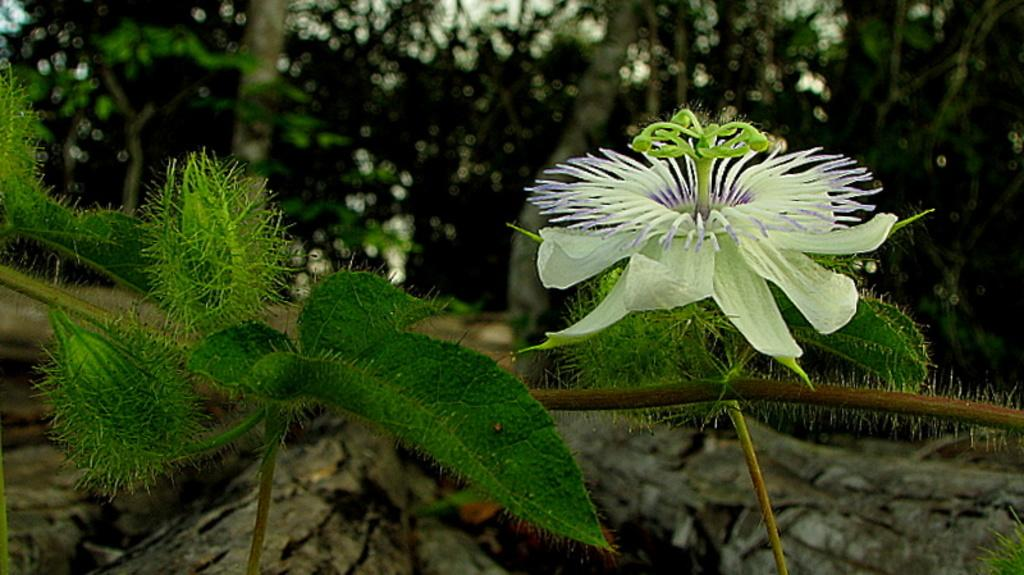What type of flora can be seen in the image? There are flowers and plants in the image. What other elements related to flora are present in the image? There are trunks and trees in the image. How would you describe the background of the image? The background of the image is blurred. What type of brush or chalk is used to draw the flowers in the image? There is no indication that the flowers in the image were drawn or created using a brush or chalk; they appear to be real flowers. 